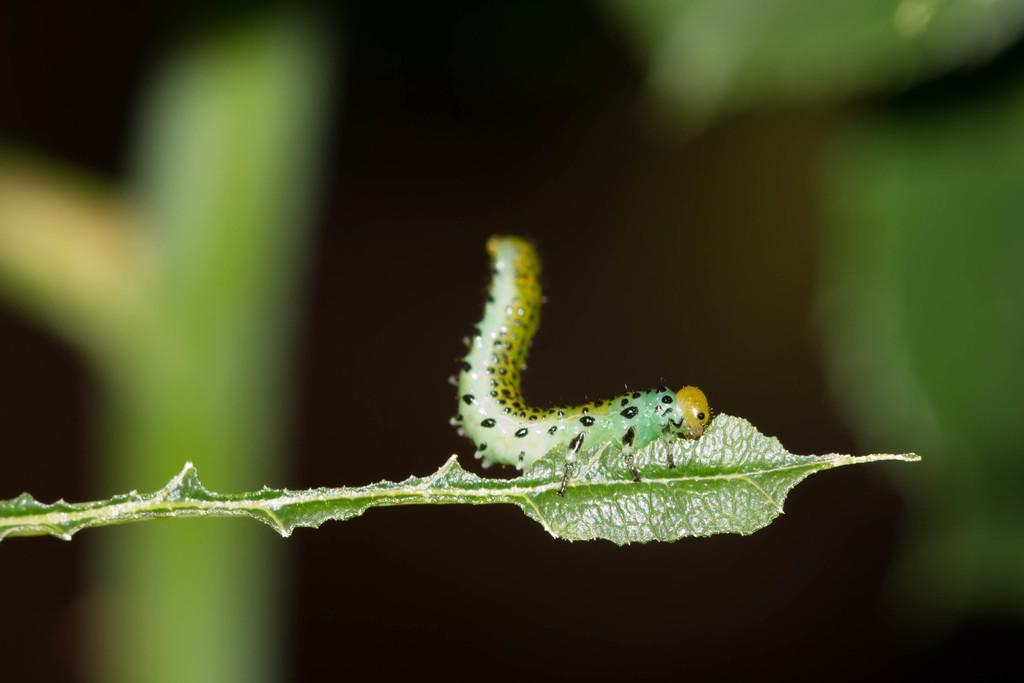What is the main subject of the image? The main subject of the image is an insect on a leaf. Can you describe the background of the image? The background of the image is blurred. What type of vein is visible on the insect in the image? There are no visible veins on the insect in the image. What event related to death is depicted in the image? There is no event related to death depicted in the image; it features an insect on a leaf. Can you see a balloon in the image? There is no balloon present in the image. 